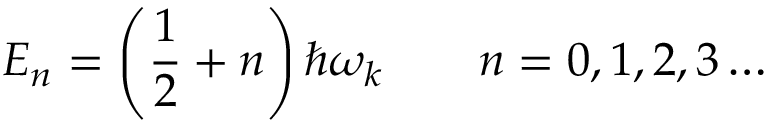Convert formula to latex. <formula><loc_0><loc_0><loc_500><loc_500>E _ { n } = \left ( { \frac { 1 } { 2 } } + n \right ) \hbar { \omega } _ { k } \quad n = 0 , 1 , 2 , 3 \dots</formula> 